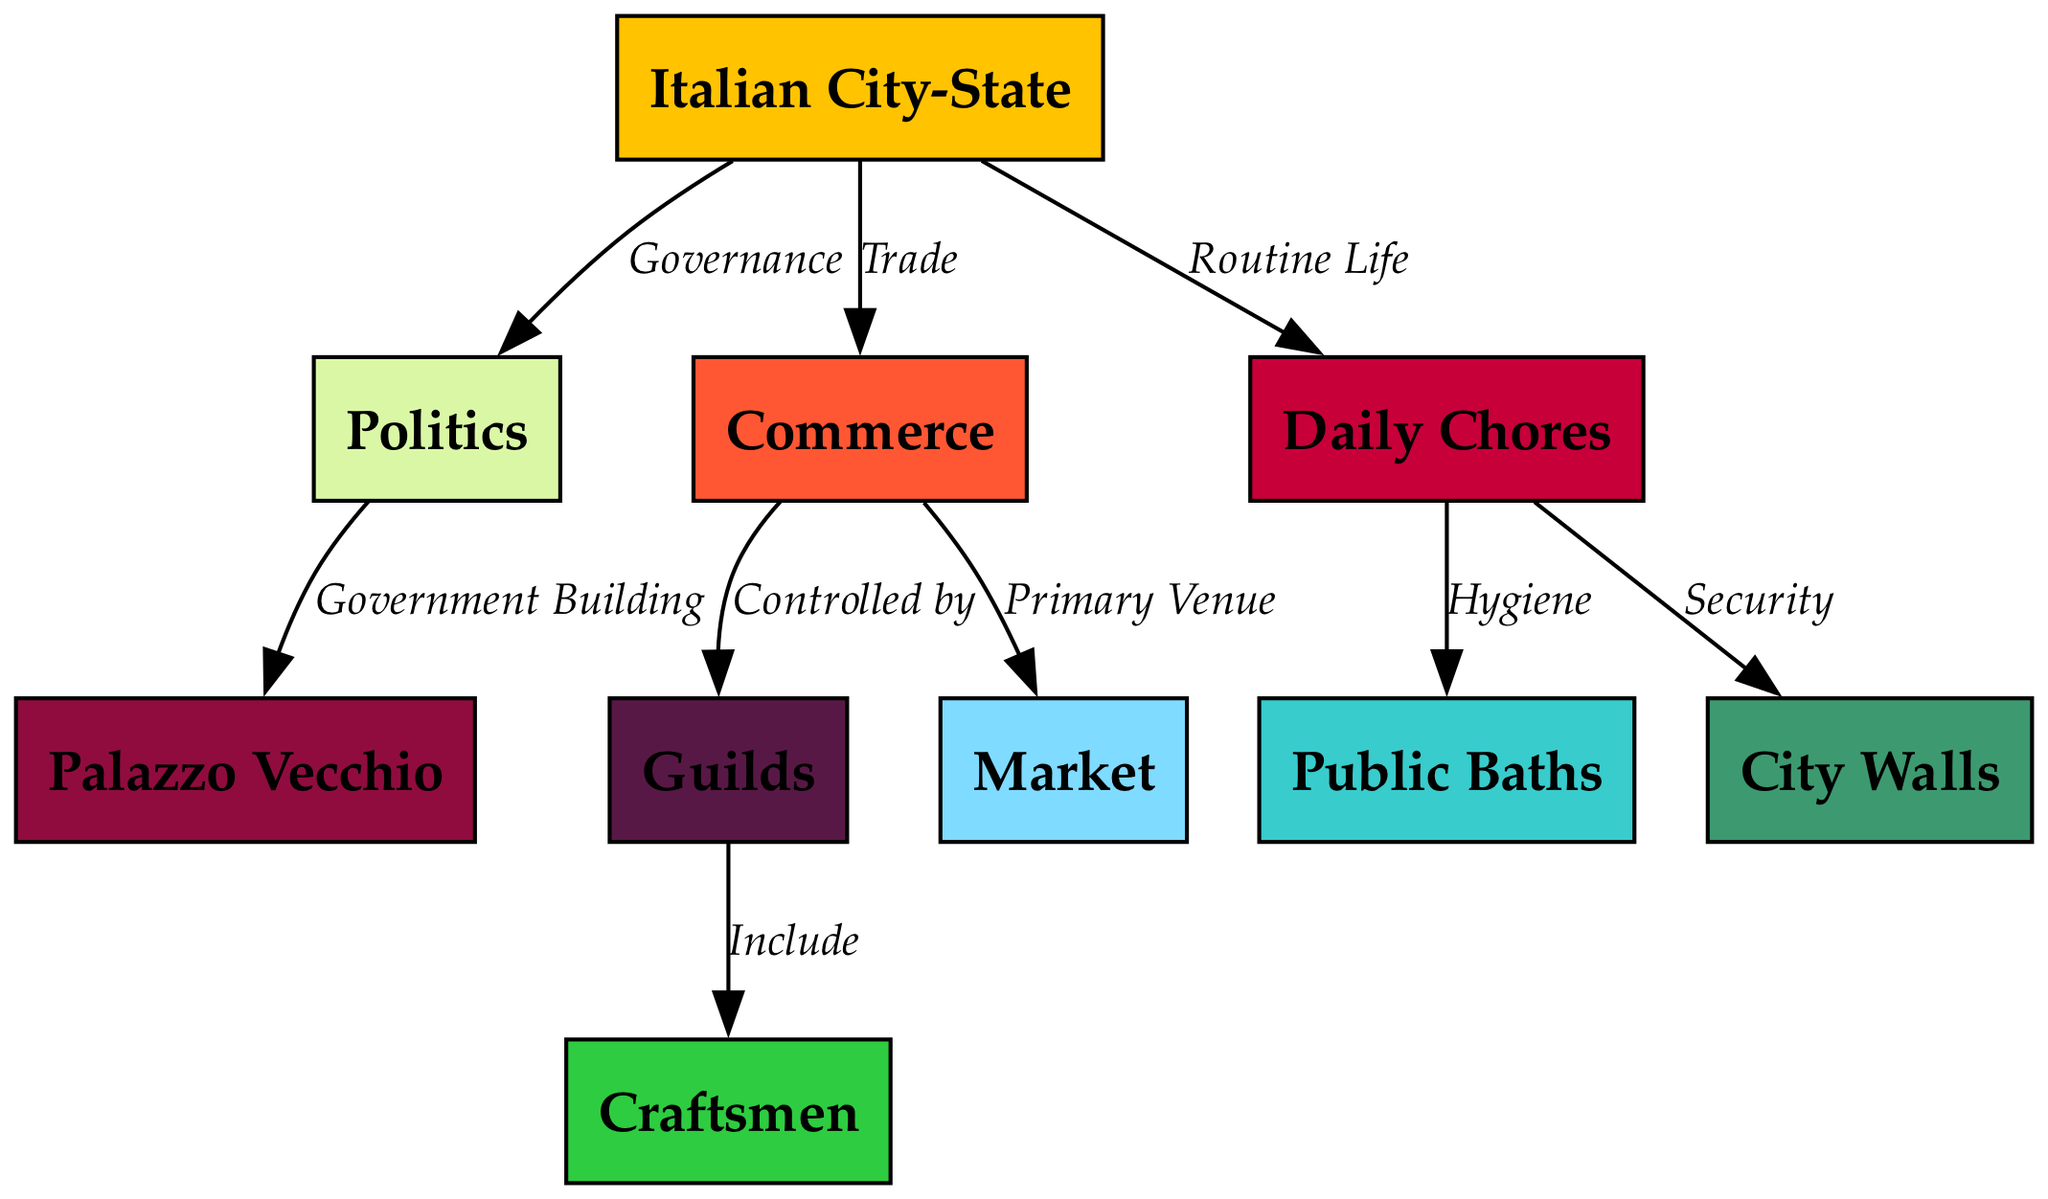What is the main subject of the diagram? The diagram focuses on the "Italian City-State," which serves as the central node from which other aspects are connected.
Answer: Italian City-State How many nodes are present in the diagram? By counting all the unique nodes in the diagram, we find there are 10 nodes listed, each representing different aspects of life in an Italian City-State.
Answer: 10 What is the primary connection from Politics? The connection leading from "Politics" points to "Palazzo Vecchio," indicating that this government building is tied to governance activities.
Answer: Palazzo Vecchio Which node is connected to Commerce? The node directly linked to "Commerce" is "Guilds," showcasing a relationship where commerce activities are controlled by various guilds.
Answer: Guilds What do Daily Chores relate to in terms of hygiene? The "Daily Chores" node connects to "Public Baths," which emphasizes the role of these baths in maintaining hygiene within daily life.
Answer: Public Baths How do Craftsmen relate to the Guilds? Craftsmen are included under the Guilds node, indicating that they are part of organized groups in the context of commerce and trades.
Answer: Include What is the role of the Market in Commerce? The "Market" serves as the primary venue of commerce, illustrating its importance in trade activities within the city-state.
Answer: Primary Venue What two aspects are linked to Daily Chores? Daily Chores are connected to both "Public Baths" and "City Walls," indicating facets of hygiene and security within routine life.
Answer: Public Baths and City Walls How is security represented in the diagram? Security is tied to "City Walls," which indicates that these walls provide protection and safety for the inhabitants of the city-state.
Answer: City Walls 